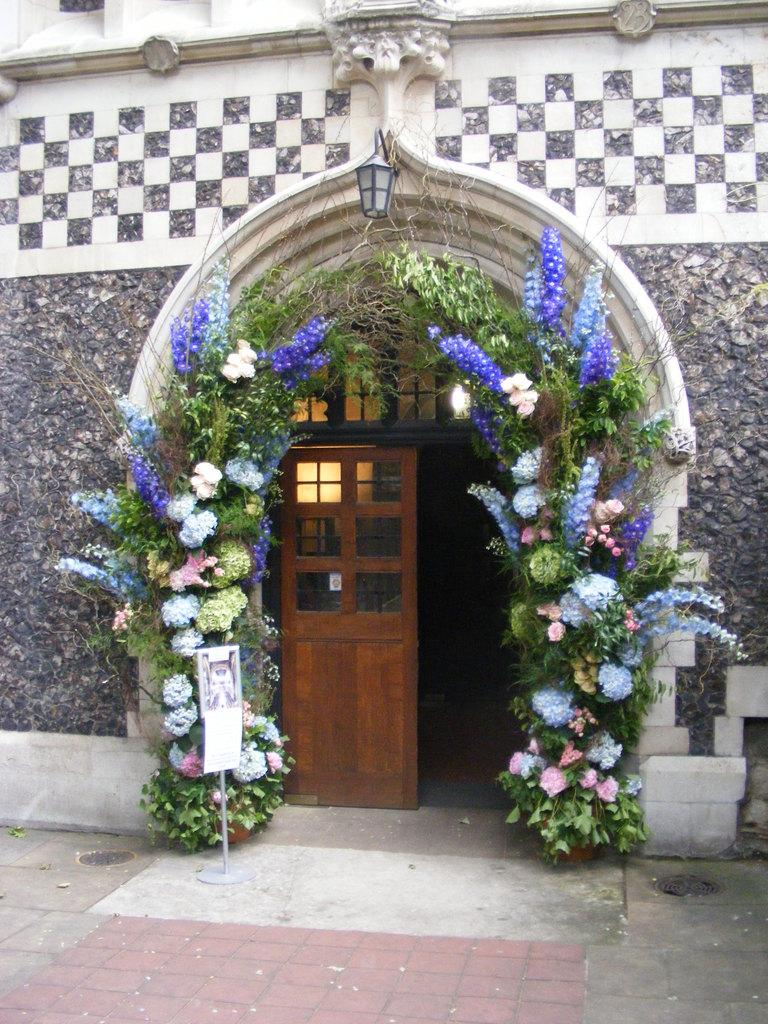What type of structure is present in the image? There is a building in the image. What is a feature of the building that can be used for entering or exiting? There is a door in the image. What can be seen leading to the building? There is a path in the image. What type of decoration is present in the image? There is decoration with leaves and flowers in the image. How many owls are sitting on the wall in the image? There are no owls present in the image. What type of ball can be seen bouncing on the path in the image? There is no ball present in the image. 